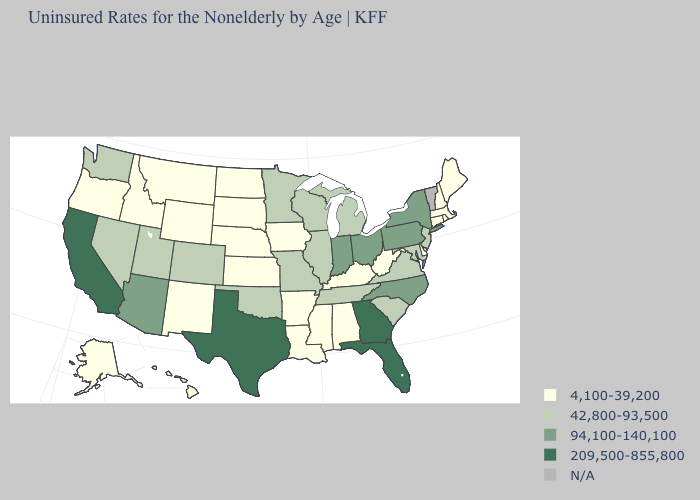Does the map have missing data?
Write a very short answer. Yes. Which states hav the highest value in the MidWest?
Short answer required. Indiana, Ohio. Name the states that have a value in the range 94,100-140,100?
Be succinct. Arizona, Indiana, New York, North Carolina, Ohio, Pennsylvania. What is the highest value in the USA?
Keep it brief. 209,500-855,800. Does California have the highest value in the USA?
Quick response, please. Yes. Which states have the lowest value in the USA?
Write a very short answer. Alabama, Alaska, Arkansas, Connecticut, Delaware, Hawaii, Idaho, Iowa, Kansas, Kentucky, Louisiana, Maine, Massachusetts, Mississippi, Montana, Nebraska, New Hampshire, New Mexico, North Dakota, Oregon, Rhode Island, South Dakota, West Virginia, Wyoming. What is the highest value in states that border West Virginia?
Concise answer only. 94,100-140,100. Which states hav the highest value in the MidWest?
Concise answer only. Indiana, Ohio. Which states have the lowest value in the USA?
Concise answer only. Alabama, Alaska, Arkansas, Connecticut, Delaware, Hawaii, Idaho, Iowa, Kansas, Kentucky, Louisiana, Maine, Massachusetts, Mississippi, Montana, Nebraska, New Hampshire, New Mexico, North Dakota, Oregon, Rhode Island, South Dakota, West Virginia, Wyoming. What is the lowest value in states that border Georgia?
Quick response, please. 4,100-39,200. What is the value of North Dakota?
Quick response, please. 4,100-39,200. Which states hav the highest value in the MidWest?
Answer briefly. Indiana, Ohio. What is the value of Utah?
Short answer required. 42,800-93,500. 